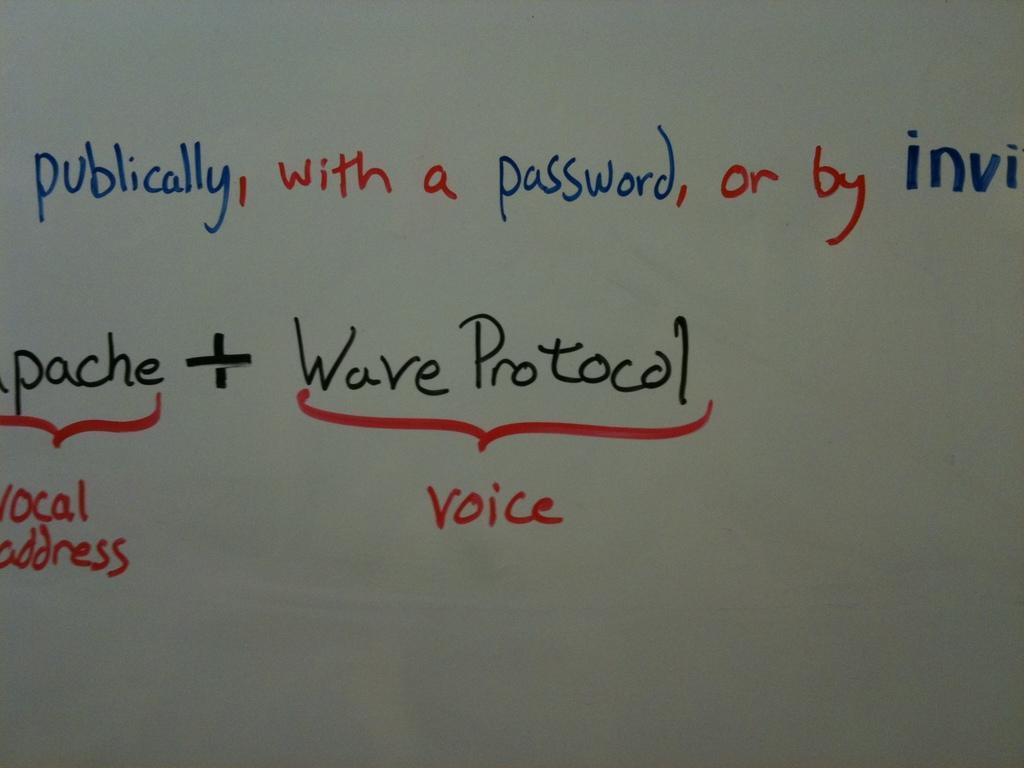How would you summarize this image in a sentence or two? In this image we can see some text on the surface. 